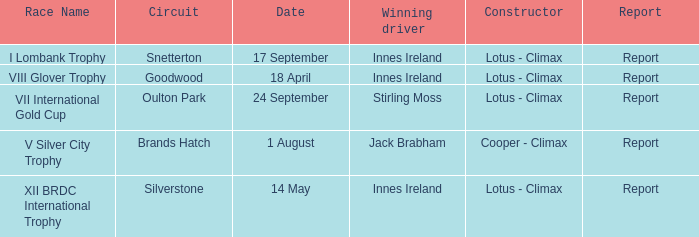What is the name of the race where Stirling Moss was the winning driver? VII International Gold Cup. 